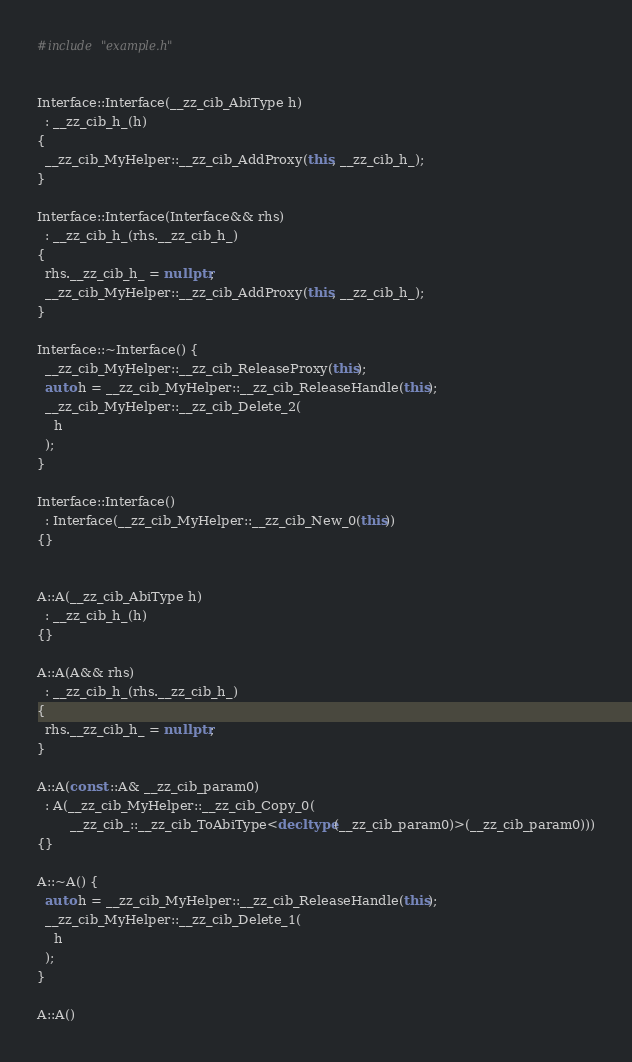<code> <loc_0><loc_0><loc_500><loc_500><_C++_>#include "example.h"


Interface::Interface(__zz_cib_AbiType h)
  : __zz_cib_h_(h)
{
  __zz_cib_MyHelper::__zz_cib_AddProxy(this, __zz_cib_h_);
}

Interface::Interface(Interface&& rhs)
  : __zz_cib_h_(rhs.__zz_cib_h_)
{
  rhs.__zz_cib_h_ = nullptr;
  __zz_cib_MyHelper::__zz_cib_AddProxy(this, __zz_cib_h_);
}

Interface::~Interface() {
  __zz_cib_MyHelper::__zz_cib_ReleaseProxy(this);
  auto h = __zz_cib_MyHelper::__zz_cib_ReleaseHandle(this);
  __zz_cib_MyHelper::__zz_cib_Delete_2(
    h
  );
}

Interface::Interface()
  : Interface(__zz_cib_MyHelper::__zz_cib_New_0(this))
{}


A::A(__zz_cib_AbiType h)
  : __zz_cib_h_(h)
{}

A::A(A&& rhs)
  : __zz_cib_h_(rhs.__zz_cib_h_)
{
  rhs.__zz_cib_h_ = nullptr;
}

A::A(const ::A& __zz_cib_param0)
  : A(__zz_cib_MyHelper::__zz_cib_Copy_0(
        __zz_cib_::__zz_cib_ToAbiType<decltype(__zz_cib_param0)>(__zz_cib_param0)))
{}

A::~A() {
  auto h = __zz_cib_MyHelper::__zz_cib_ReleaseHandle(this);
  __zz_cib_MyHelper::__zz_cib_Delete_1(
    h
  );
}

A::A()</code> 